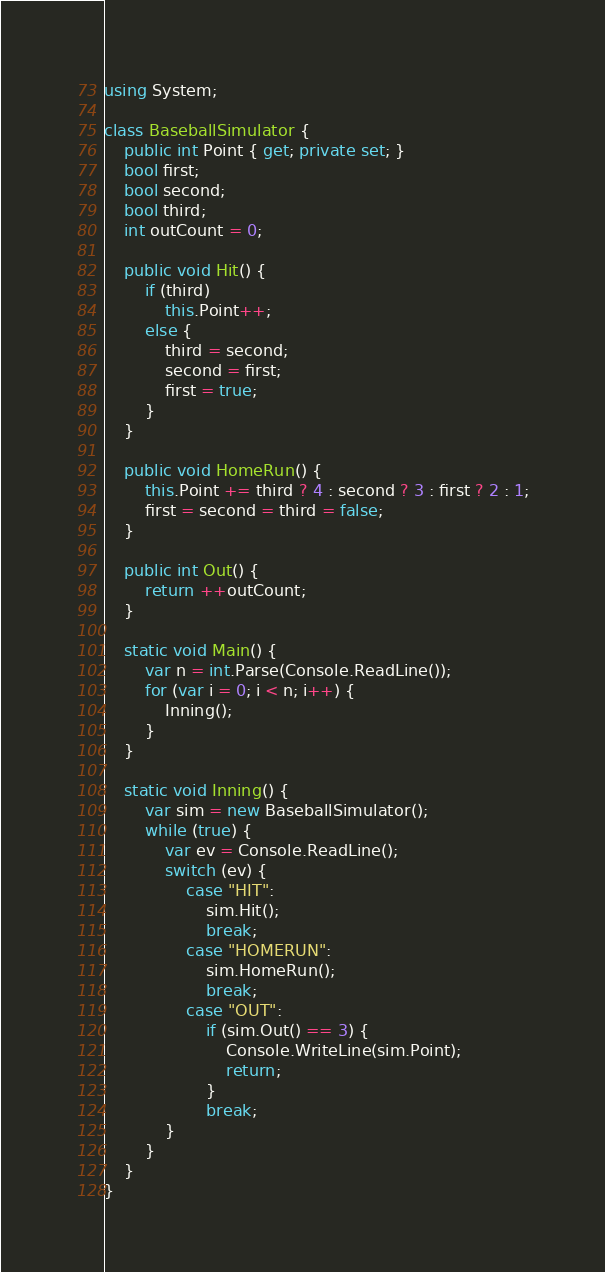Convert code to text. <code><loc_0><loc_0><loc_500><loc_500><_C#_>using System;

class BaseballSimulator {
    public int Point { get; private set; }
    bool first;
    bool second;
    bool third;
    int outCount = 0;

    public void Hit() {
        if (third)
            this.Point++;
        else {
            third = second;
            second = first;
            first = true;
        }
    }

    public void HomeRun() {
        this.Point += third ? 4 : second ? 3 : first ? 2 : 1;
        first = second = third = false;
    }

    public int Out() {
        return ++outCount;
    }

    static void Main() {
        var n = int.Parse(Console.ReadLine());
        for (var i = 0; i < n; i++) {
            Inning();
        }
    }

    static void Inning() {
        var sim = new BaseballSimulator();
        while (true) {
            var ev = Console.ReadLine();
            switch (ev) {
                case "HIT":
                    sim.Hit();
                    break;
                case "HOMERUN":
                    sim.HomeRun();
                    break;
                case "OUT":
                    if (sim.Out() == 3) {
                        Console.WriteLine(sim.Point);
                        return;
                    }
                    break;
            }
        }
    }
}</code> 